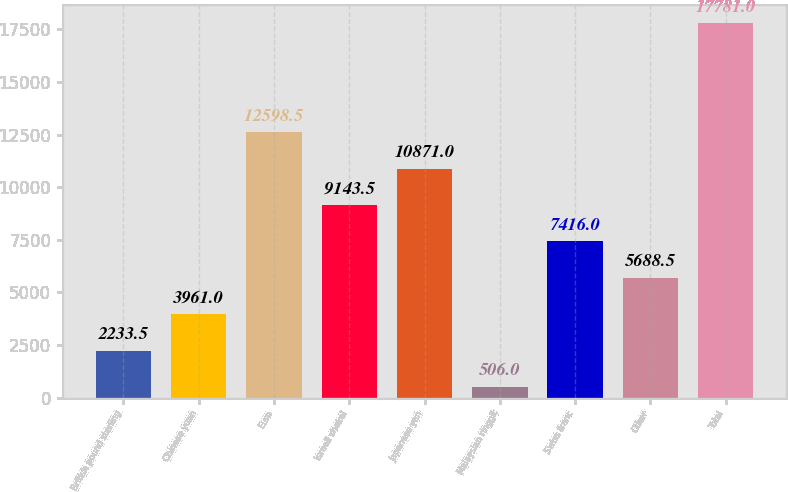<chart> <loc_0><loc_0><loc_500><loc_500><bar_chart><fcel>British pound sterling<fcel>Chinese yuan<fcel>Euro<fcel>Israeli shekel<fcel>Japanese yen<fcel>Malaysian ringgit<fcel>Swiss franc<fcel>Other<fcel>Total<nl><fcel>2233.5<fcel>3961<fcel>12598.5<fcel>9143.5<fcel>10871<fcel>506<fcel>7416<fcel>5688.5<fcel>17781<nl></chart> 